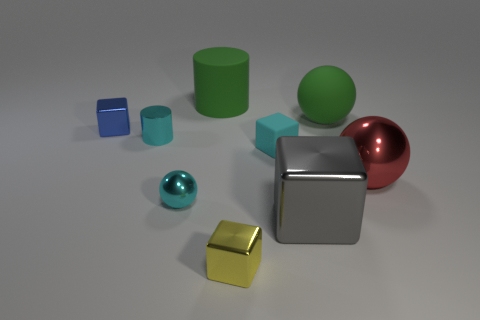Subtract 1 cubes. How many cubes are left? 3 Add 1 tiny cylinders. How many objects exist? 10 Subtract all cylinders. How many objects are left? 7 Add 7 green cylinders. How many green cylinders exist? 8 Subtract 0 blue cylinders. How many objects are left? 9 Subtract all blue blocks. Subtract all tiny cyan metallic cubes. How many objects are left? 8 Add 8 tiny rubber cubes. How many tiny rubber cubes are left? 9 